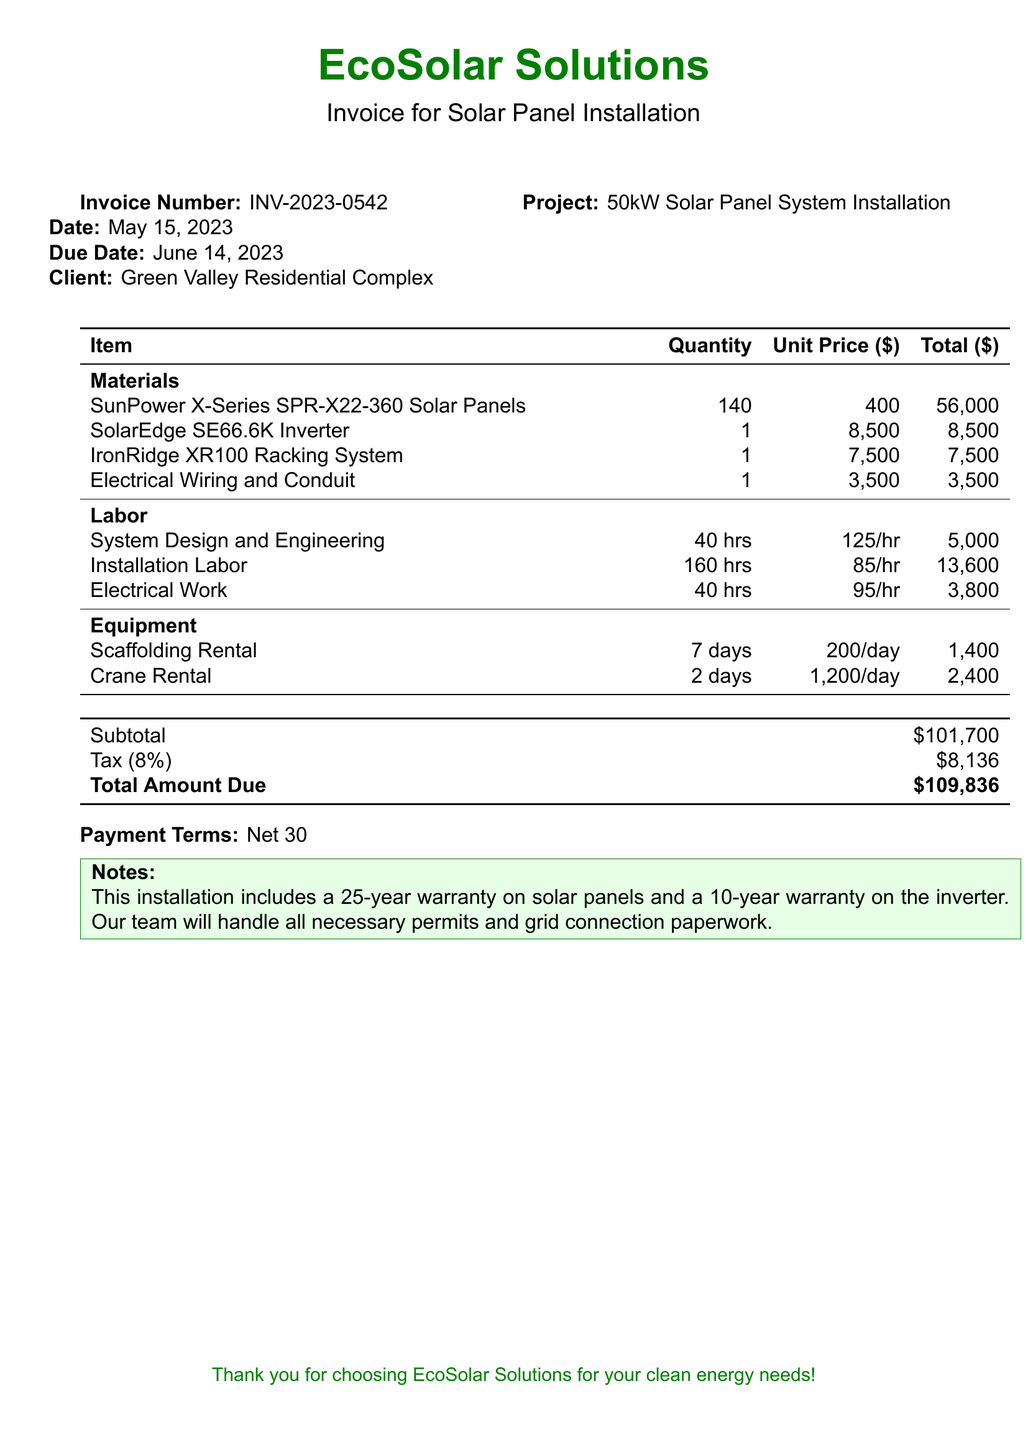What is the invoice number? The invoice number appears near the top of the document under "Invoice Number".
Answer: INV-2023-0542 What is the total amount due? The total amount due is calculated as the subtotal plus tax. This information is at the bottom of the invoice.
Answer: $109,836 How many solar panels are included in the installation? The quantity of solar panels is listed in the materials section of the invoice.
Answer: 140 What is the date of the invoice? The date is mentioned next to "Date" near the top of the document.
Answer: May 15, 2023 What is the unit price of the SolarEdge inverter? The unit price details for the inverter can be found in the materials section.
Answer: $8,500 What is the subtotal before tax? The subtotal is specified in the summary section of the invoice.
Answer: $101,700 How many hours of electrical work are estimated? The hours for electrical work are mentioned under the labor section.
Answer: 40 hrs What is included in the warranty for the solar panels? Notes about the warranty can be found towards the end of the document.
Answer: 25-year warranty What is the payment term mentioned? The payment terms are indicated in a section near the end of the document.
Answer: Net 30 